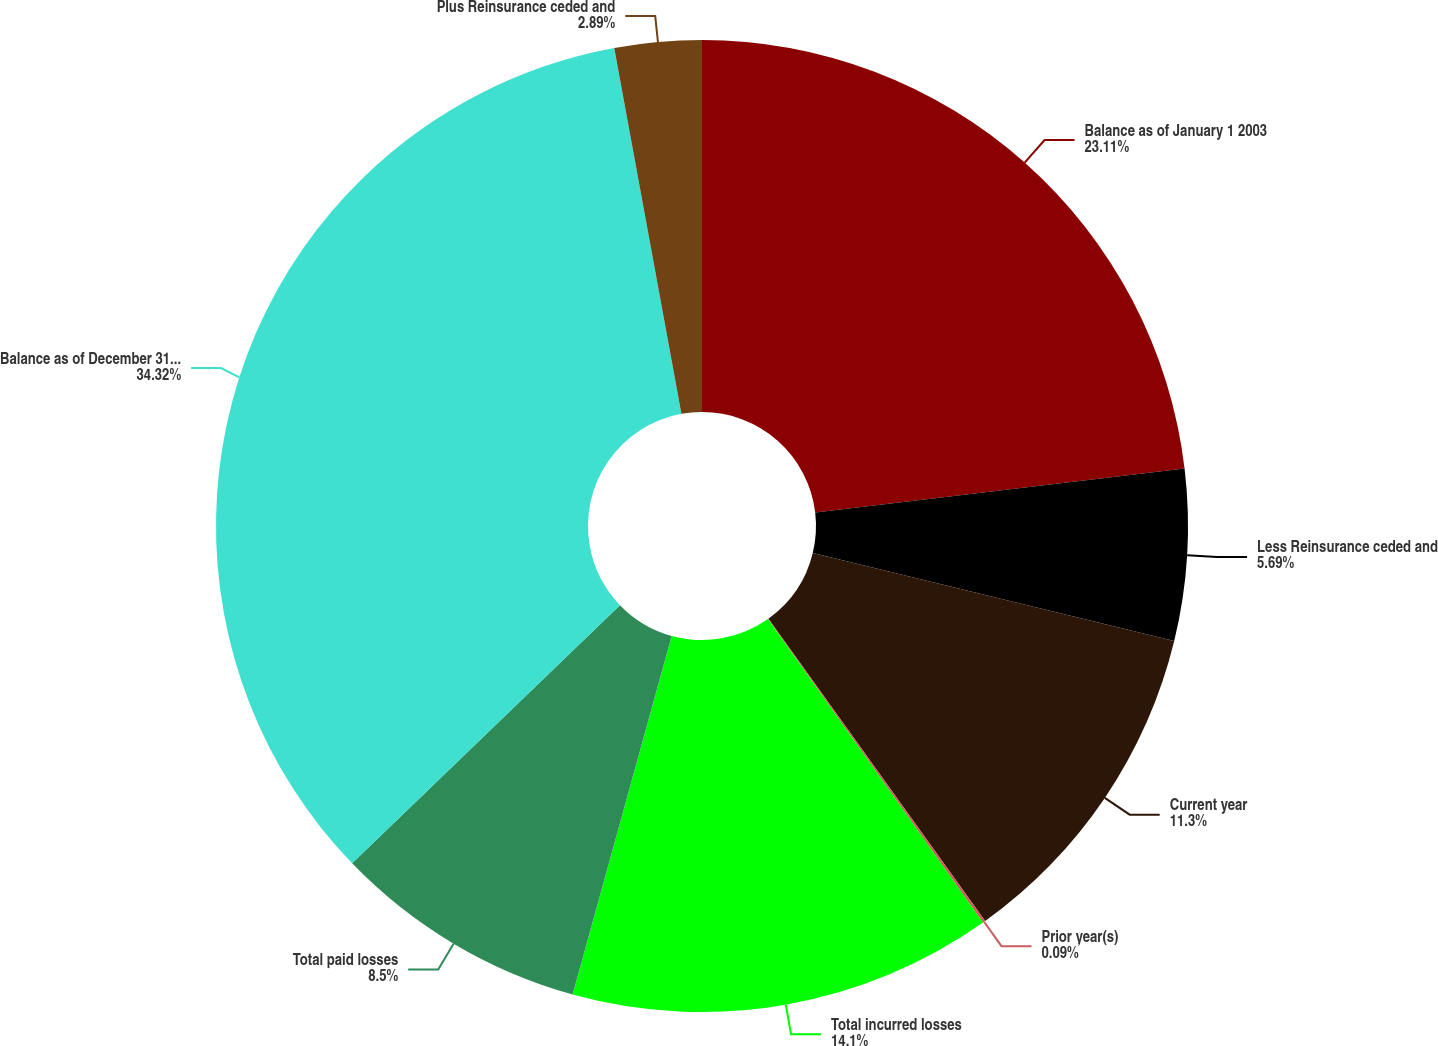Convert chart. <chart><loc_0><loc_0><loc_500><loc_500><pie_chart><fcel>Balance as of January 1 2003<fcel>Less Reinsurance ceded and<fcel>Current year<fcel>Prior year(s)<fcel>Total incurred losses<fcel>Total paid losses<fcel>Balance as of December 31 2003<fcel>Plus Reinsurance ceded and<nl><fcel>23.11%<fcel>5.69%<fcel>11.3%<fcel>0.09%<fcel>14.1%<fcel>8.5%<fcel>34.32%<fcel>2.89%<nl></chart> 